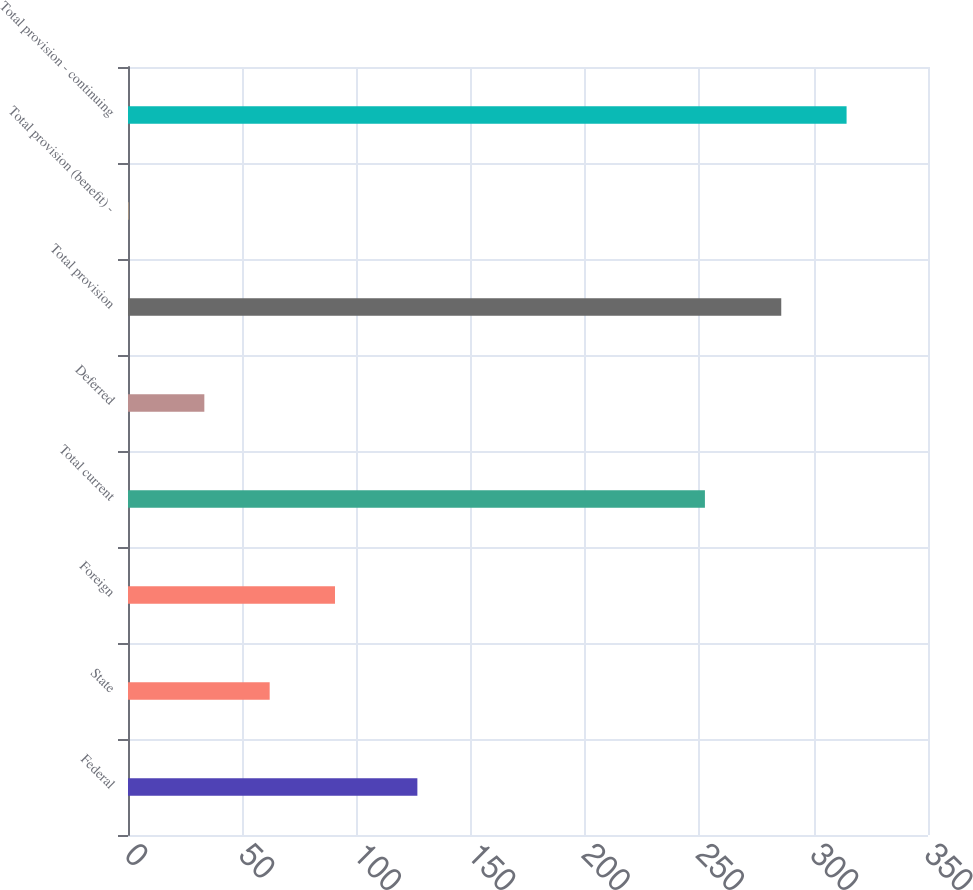Convert chart. <chart><loc_0><loc_0><loc_500><loc_500><bar_chart><fcel>Federal<fcel>State<fcel>Foreign<fcel>Total current<fcel>Deferred<fcel>Total provision<fcel>Total provision (benefit) -<fcel>Total provision - continuing<nl><fcel>126.6<fcel>61.98<fcel>90.56<fcel>252.4<fcel>33.4<fcel>285.8<fcel>0.2<fcel>314.38<nl></chart> 